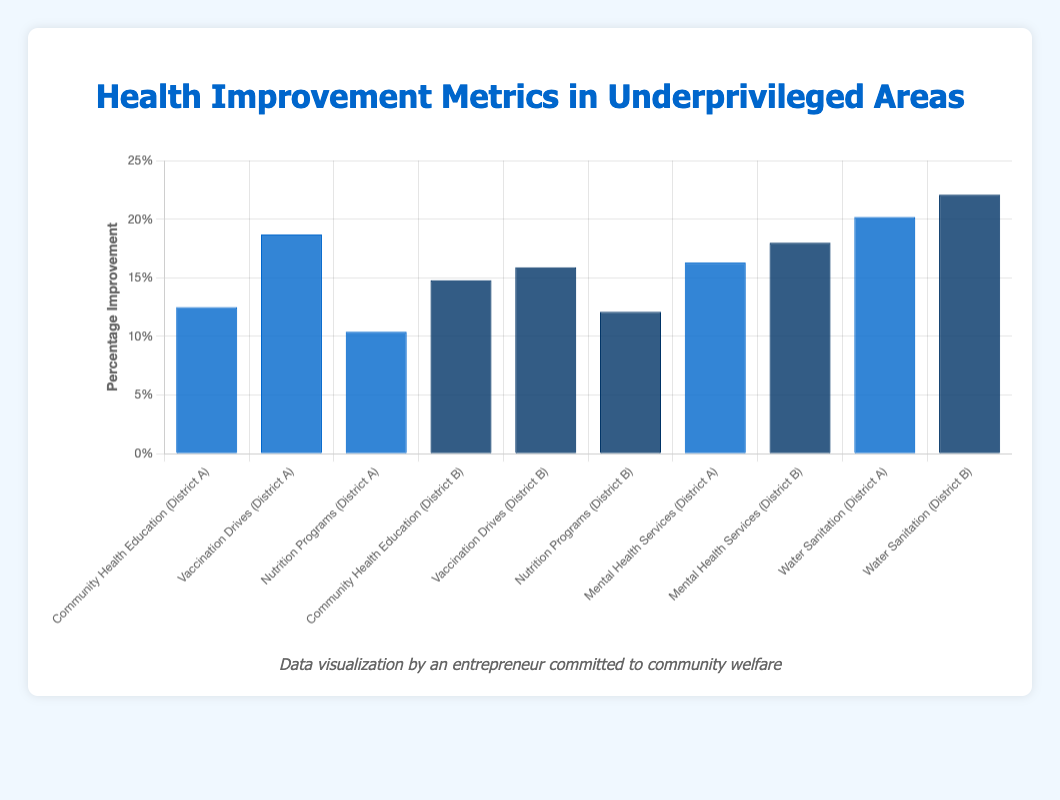Which initiative had the highest percentage improvement in District A in 2021? To find the answer, look at the height of each bar corresponding to initiatives in District A for the year 2021. The tallest bar represents 'Water Sanitation' with a 20.2% improvement.
Answer: Water Sanitation What is the sum of percentage improvements for Community Health Education initiatives across both districts? Community Health Education had a percentage improvement of 12.5% in District A in 2021 and 14.8% in District B in 2022. Summing these gives 12.5 + 14.8 = 27.3%.
Answer: 27.3% Which initiative received the lowest public funding in District A in 2021? Look at the tooltip information for each bar corresponding to District A for 2021 and compare public funding amounts. The lowest is 'Nutrition Programs' with $80,000.
Answer: Nutrition Programs Is the percentage improvement for Mental Health Services in District B greater than that in District A? Compare the heights of the bars for 'Mental Health Services' in District B (18.0%) and District A (16.3%). Yes, 18.0% is greater than 16.3%.
Answer: Yes What is the average percentage improvement for all initiatives in District B for 2022? List improvements in District B for 2022: 14.8% (Community Health Education), 15.9% (Vaccination Drives), 12.1% (Nutrition Programs), 18.0% (Mental Health Services), 22.1% (Water Sanitation). Sum these: 14.8 + 15.9 + 12.1 + 18.0 + 22.1 = 82.9. Divide by the number of initiatives (5): 82.9 / 5 = 16.58%.
Answer: 16.58% How does the percentage improvement of Vaccination Drives in District A compare to that in District B? Compare the heights of the bars for 'Vaccination Drives' in District A (18.7%) and District B (15.9%). 18.7% in District A is higher than 15.9% in District B.
Answer: District A's is higher Which region shows a higher percentage improvement for Water Sanitation programs? Compare the heights of the bars for 'Water Sanitation' in District A (20.2%) and District B (22.1%). The taller bar represents District B with 22.1%.
Answer: District B What is the difference in percentage improvement between Community Health Education initiatives in District A and B? Subtract the percentage improvement of Community Health Education in District A (12.5%) from that in District B (14.8%): 14.8 - 12.5 = 2.3%.
Answer: 2.3% Which initiative had the least percentage improvement in District B in 2022? Identify the shortest bar corresponding to District B for the year 2022. 'Nutrition Programs' had the least improvement with 12.1%.
Answer: Nutrition Programs 